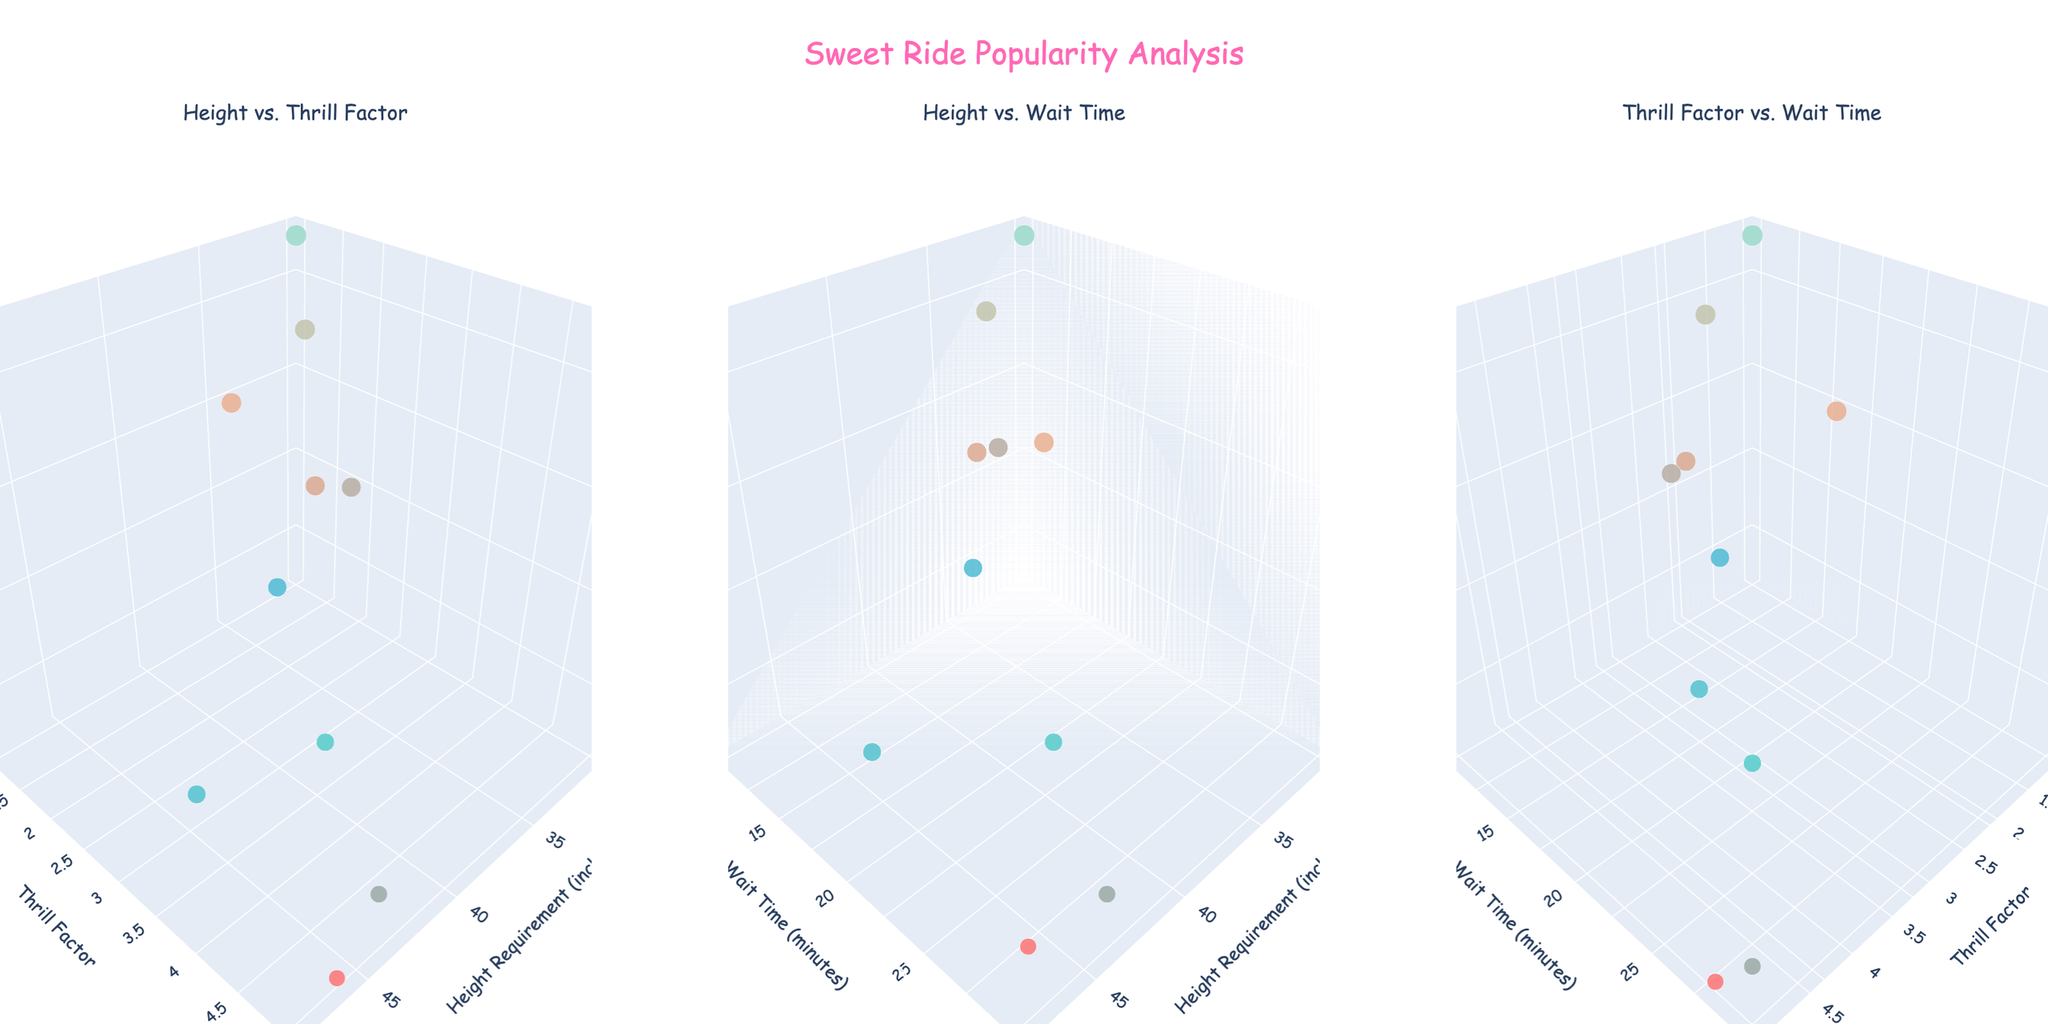How many rides are represented in the plots? You can count the number of markers (data points) in each of the subplots. Each marker represents a ride. Let’s count them in any one subplot.
Answer: 10 Which ride has the highest popularity score? Look for the largest marker (since marker size represents popularity score) and/or the marker with the highest color intensity on the z-axis (Popularity Score) in any of the subplots.
Answer: Gummy Bear Carousel What is the relationship between height requirement and thrill factor among the rides? Check the "Height vs. Thrill Factor" subplot to observe the pattern or trend.
Answer: Generally, a higher height requirement correlates with a higher thrill factor Which ride has the longest wait time, and what is its popularity score? Check the subplot with the "Height vs. Wait Time" or "Thrill Factor vs. Wait Time". The ride with the highest y-value on "Wait Time" has the longest wait, then check its corresponding z-value for popularity score.
Answer: Ice Cream Twister, 75 Is there a ride that has a high thrill factor but a low popularity score? If yes, which one? Observe the "Thrill Factor vs. Wait Time" subplot. Look for high y-values (Thrill Factor) with low z-values (Popularity Score).
Answer: Cotton Candy Cloud What's the average height requirement for the rides with a popularity score above 80? Identify the rides with popularity scores above 80 across any subplot, then average their height requirements.
Answer: (36 + 30 + 38 + 40 + 38 + 34) / 6 = 36 inches How does wait time correlate with popularity score among these rides? Check the "Height vs. Wait Time" subplot. Look for the pattern in the third dimension with respect to wait time and popularity.
Answer: Generally, longer wait times correlate with lower popularity scores Which ride has the smallest size marker in all subplots, and what are its wait time and height requirement? Identify the smallest marker across all subplots, then check the details for that ride.
Answer: Cotton Candy Cloud, 28 minutes, 46 inches Between the rides "Candy Coaster" and "Sugar Rush Rapids", which one has a higher thrill factor, and by how much? Check the "Height vs. Thrill Factor" subplot for these two rides and compare their y-values (Thrill Factor).
Answer: Sugar Rush Rapids, by 1 (4 vs. 3) Do rides with higher height requirements tend to have longer wait times? Observe the "Height vs. Wait Time" subplot for any visible trend between x-values (Height Requirement) and y-values (Wait Time).
Answer: Not always, the trend is inconsistent 